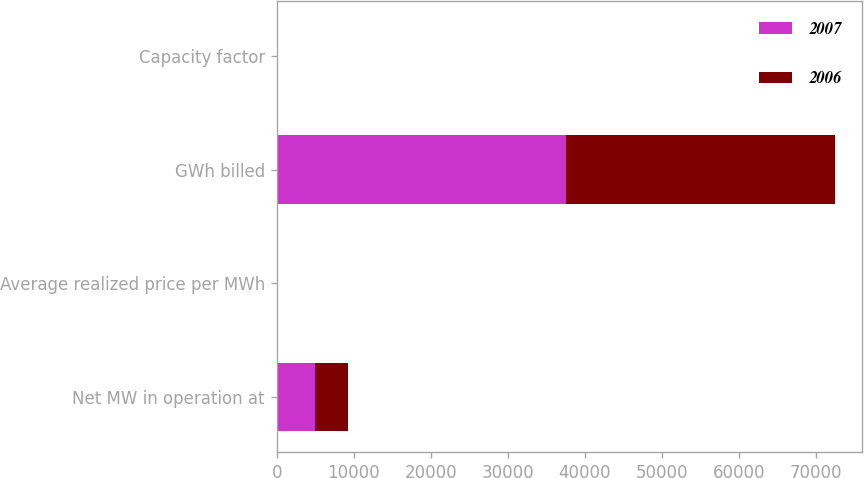Convert chart to OTSL. <chart><loc_0><loc_0><loc_500><loc_500><stacked_bar_chart><ecel><fcel>Net MW in operation at<fcel>Average realized price per MWh<fcel>GWh billed<fcel>Capacity factor<nl><fcel>2007<fcel>4998<fcel>52.69<fcel>37570<fcel>89<nl><fcel>2006<fcel>4200<fcel>44.33<fcel>34847<fcel>95<nl></chart> 